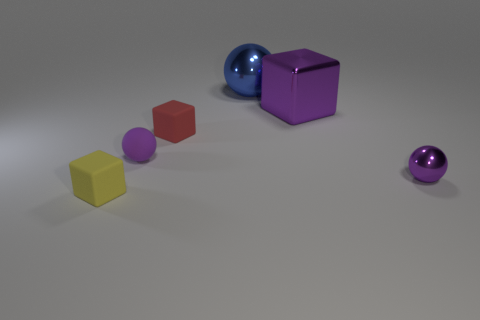What number of gray things are metallic blocks or matte spheres?
Provide a succinct answer. 0. What is the material of the object that is behind the tiny red cube and in front of the big blue thing?
Your answer should be compact. Metal. Is the large cube made of the same material as the big blue thing?
Keep it short and to the point. Yes. What number of blue spheres have the same size as the purple matte object?
Your answer should be compact. 0. Is the number of objects behind the yellow matte object the same as the number of balls?
Your answer should be compact. No. How many objects are behind the purple cube and to the left of the big blue thing?
Ensure brevity in your answer.  0. Is the shape of the shiny thing to the left of the big purple metal block the same as  the yellow matte thing?
Offer a terse response. No. There is a cube that is the same size as the yellow matte thing; what is its material?
Provide a succinct answer. Rubber. Are there the same number of small yellow rubber cubes that are to the right of the yellow rubber object and big metallic spheres behind the big cube?
Ensure brevity in your answer.  No. There is a small purple object that is to the right of the tiny block behind the yellow matte object; what number of tiny matte objects are in front of it?
Offer a terse response. 1. 